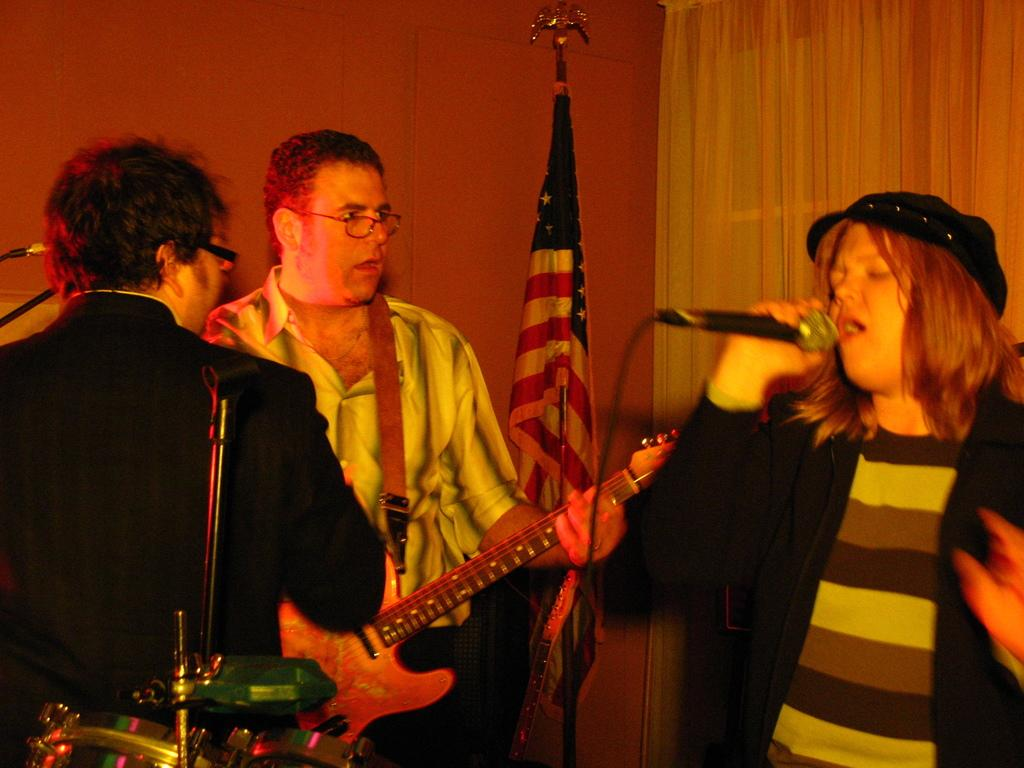What is happening in the image involving the group of people? There is a person singing and holding a microphone, and another person is holding a guitar, suggesting a musical performance. How many people are involved in the performance? There are at least two people involved in the performance, as one is singing with a microphone and another is holding a guitar. What can be seen in the background of the image? There is a flag visible in the background. What grade did the person holding the guitar receive on their last math test? There is no information about the person's grade on their last math test in the image, as it focuses on the musical performance and the presence of a flag in the background. 